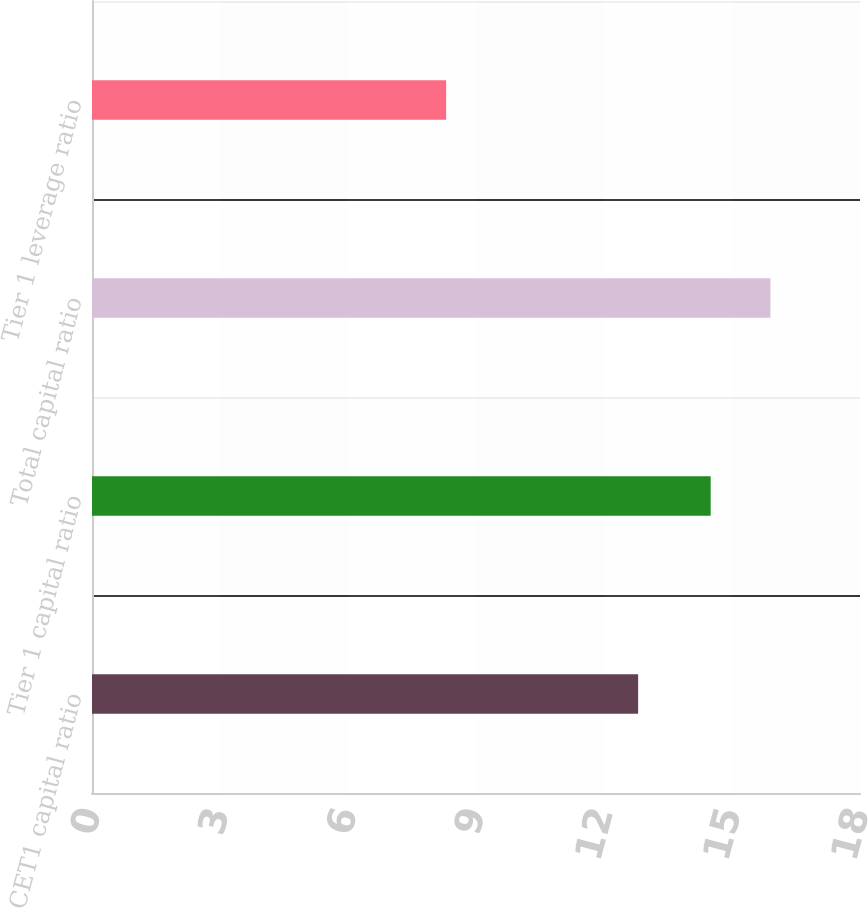Convert chart. <chart><loc_0><loc_0><loc_500><loc_500><bar_chart><fcel>CET1 capital ratio<fcel>Tier 1 capital ratio<fcel>Total capital ratio<fcel>Tier 1 leverage ratio<nl><fcel>12.8<fcel>14.5<fcel>15.9<fcel>8.3<nl></chart> 